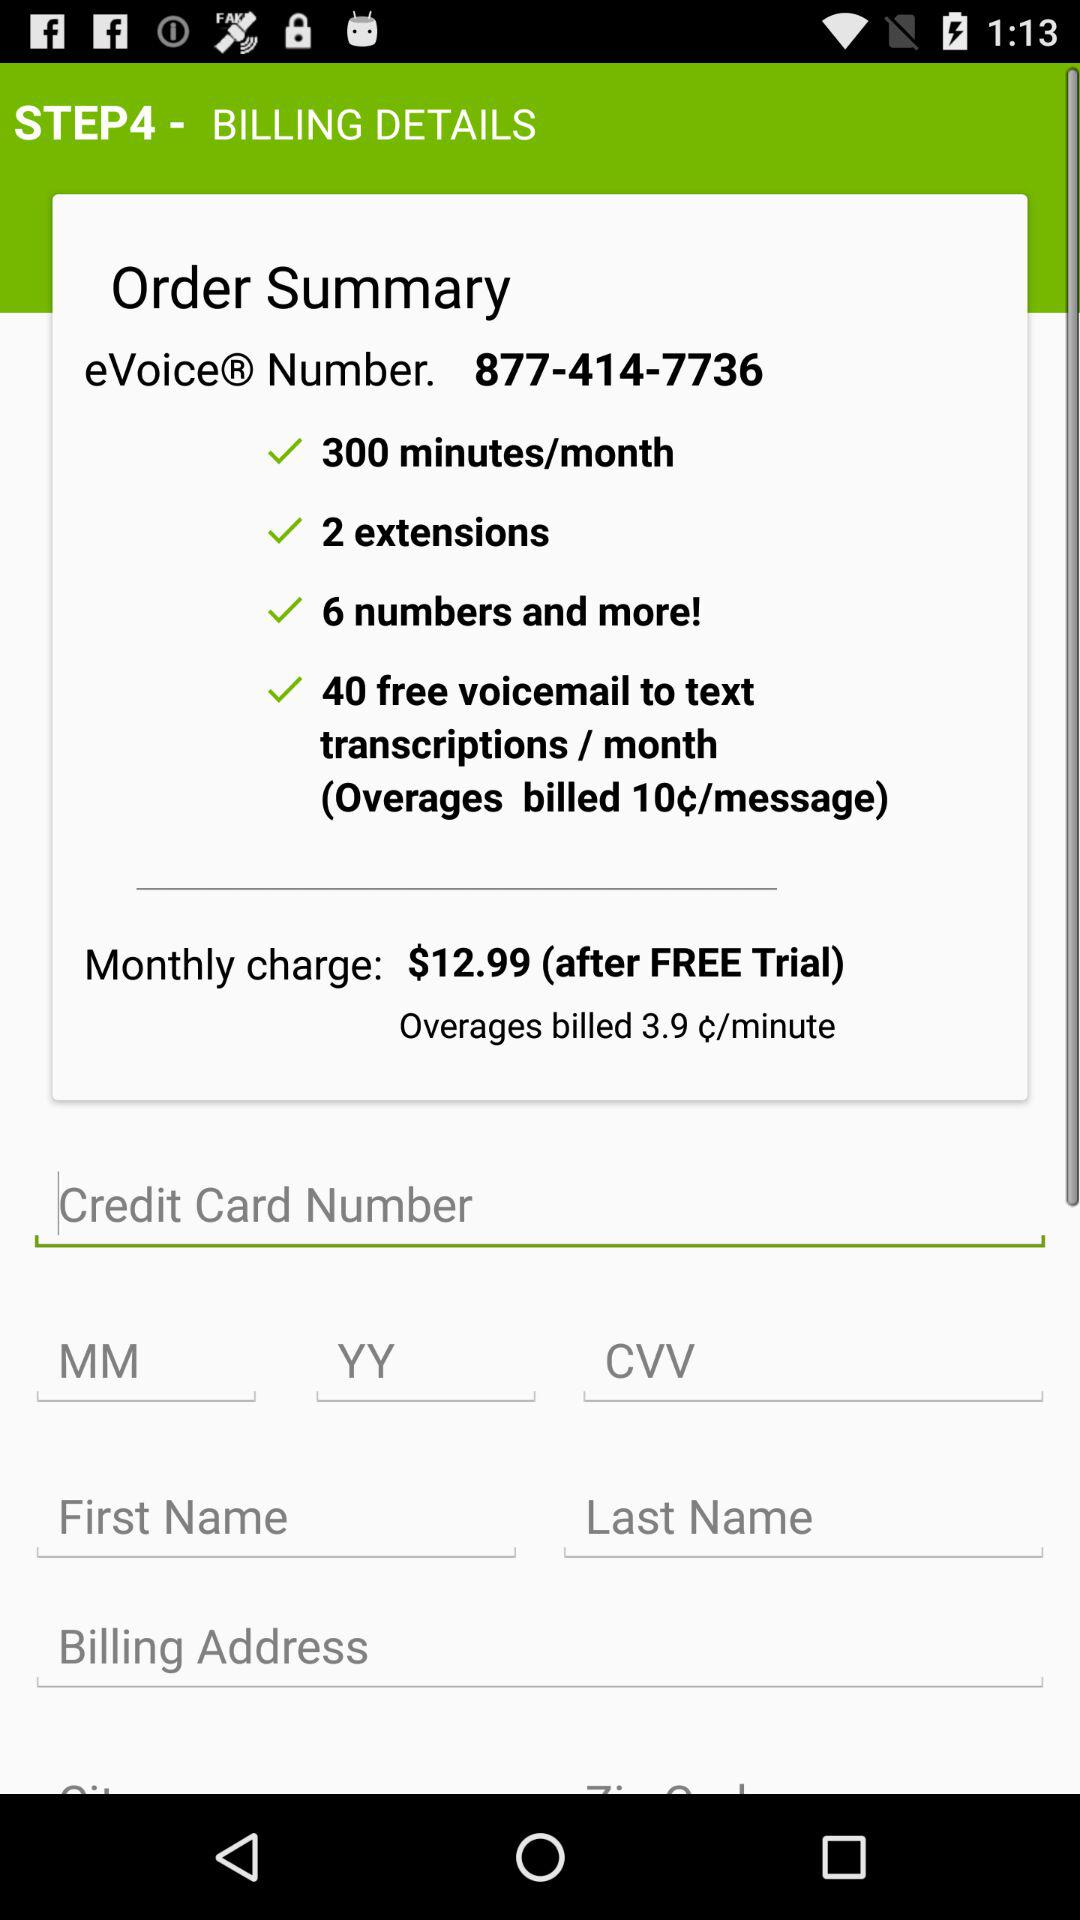At which step am I? You are at step 4. 